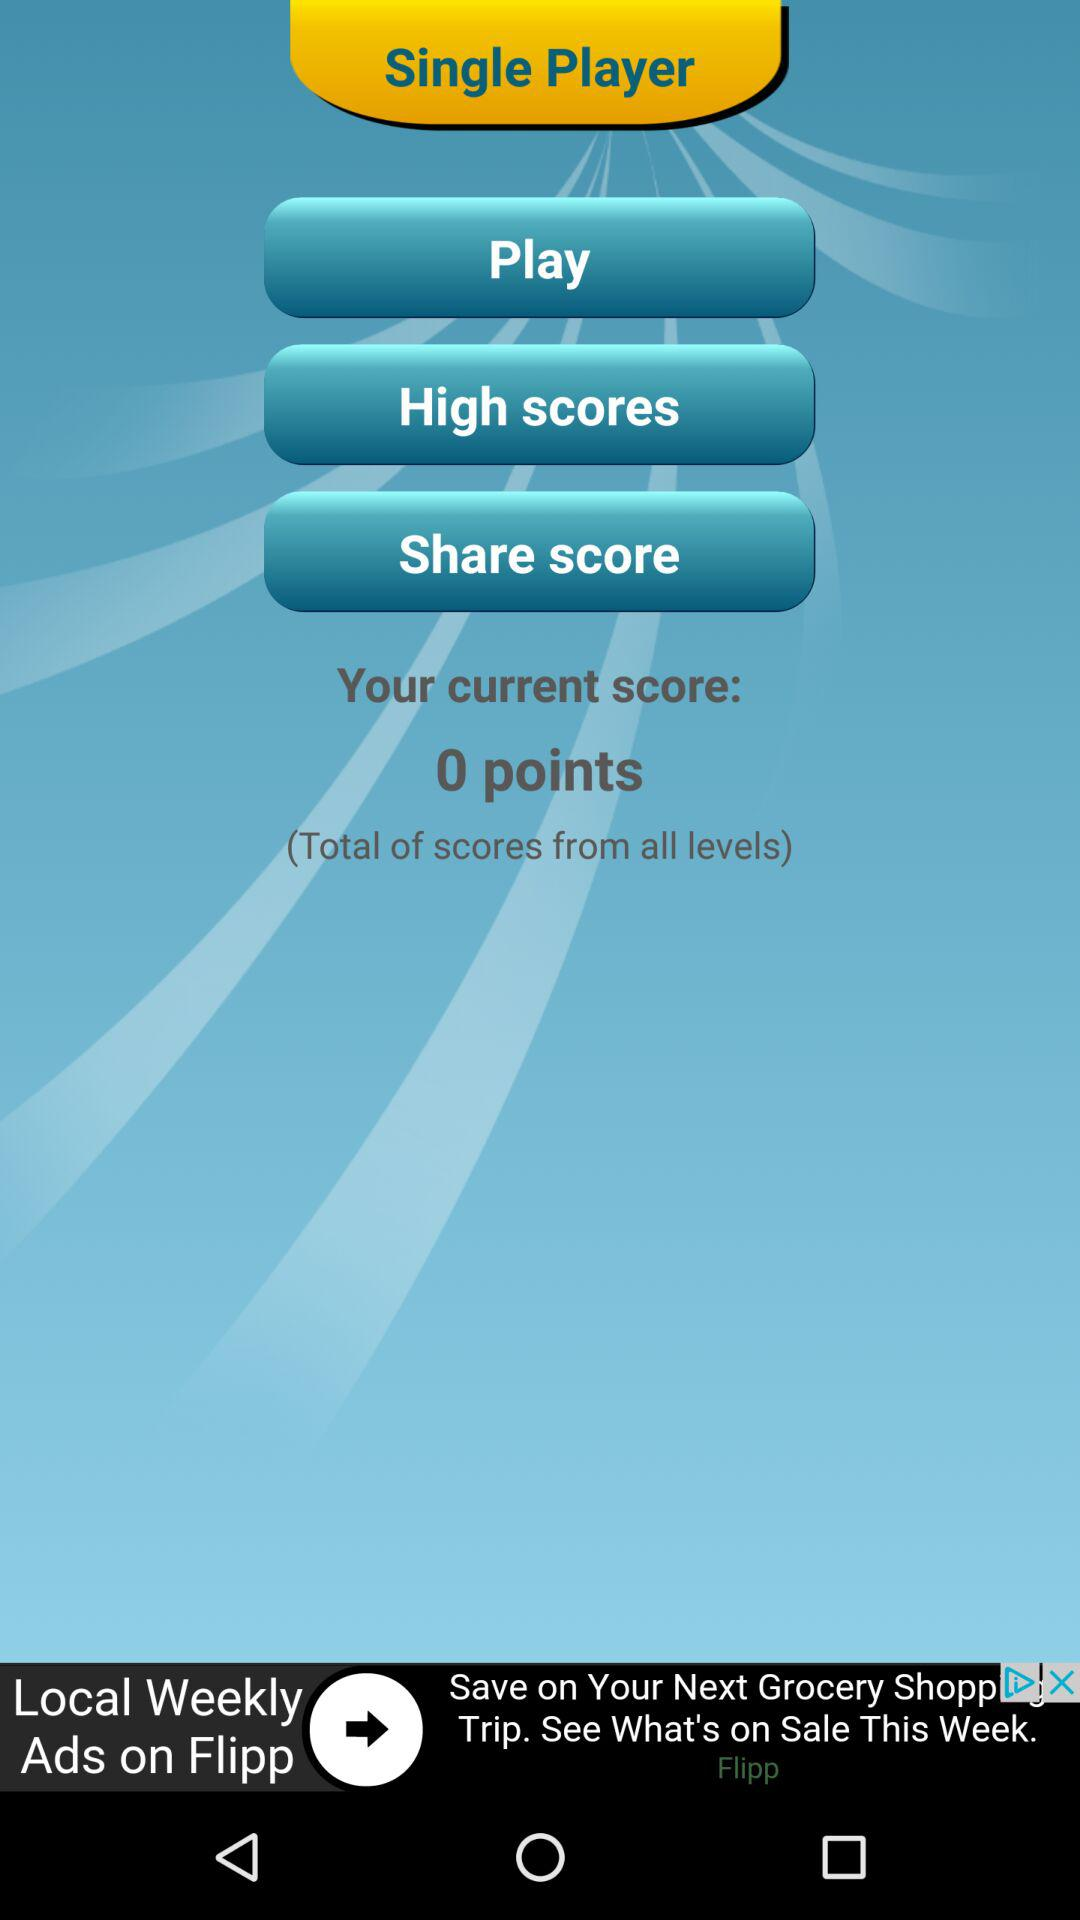What is the current score? The current score is 0 points. 